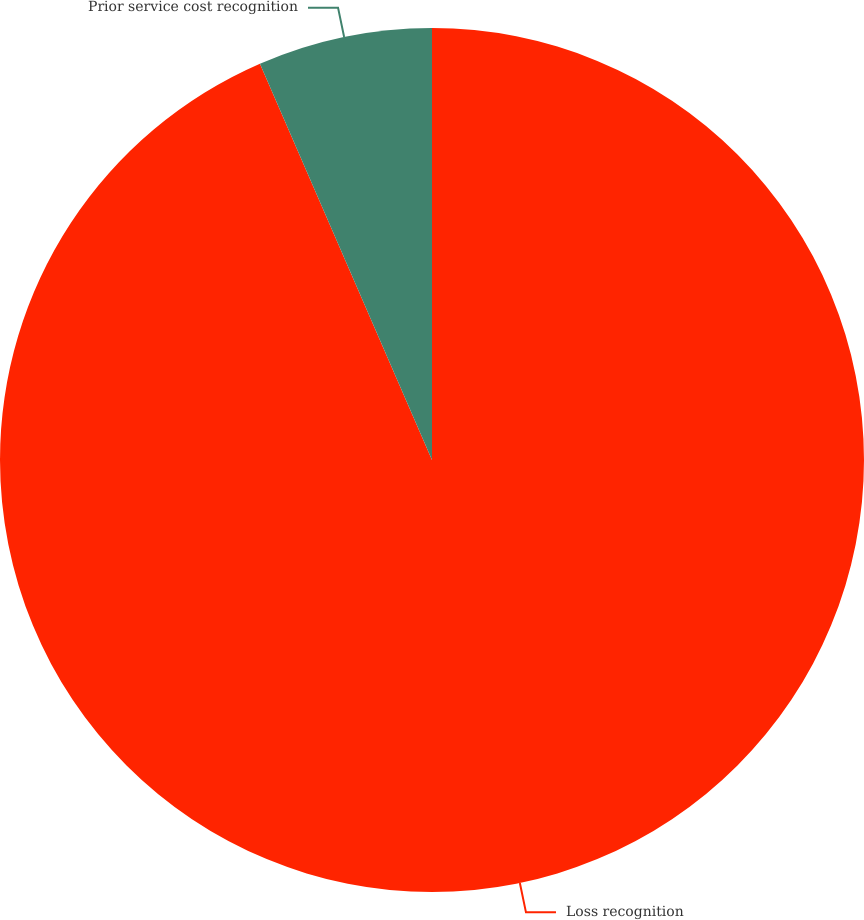Convert chart. <chart><loc_0><loc_0><loc_500><loc_500><pie_chart><fcel>Loss recognition<fcel>Prior service cost recognition<nl><fcel>93.48%<fcel>6.52%<nl></chart> 